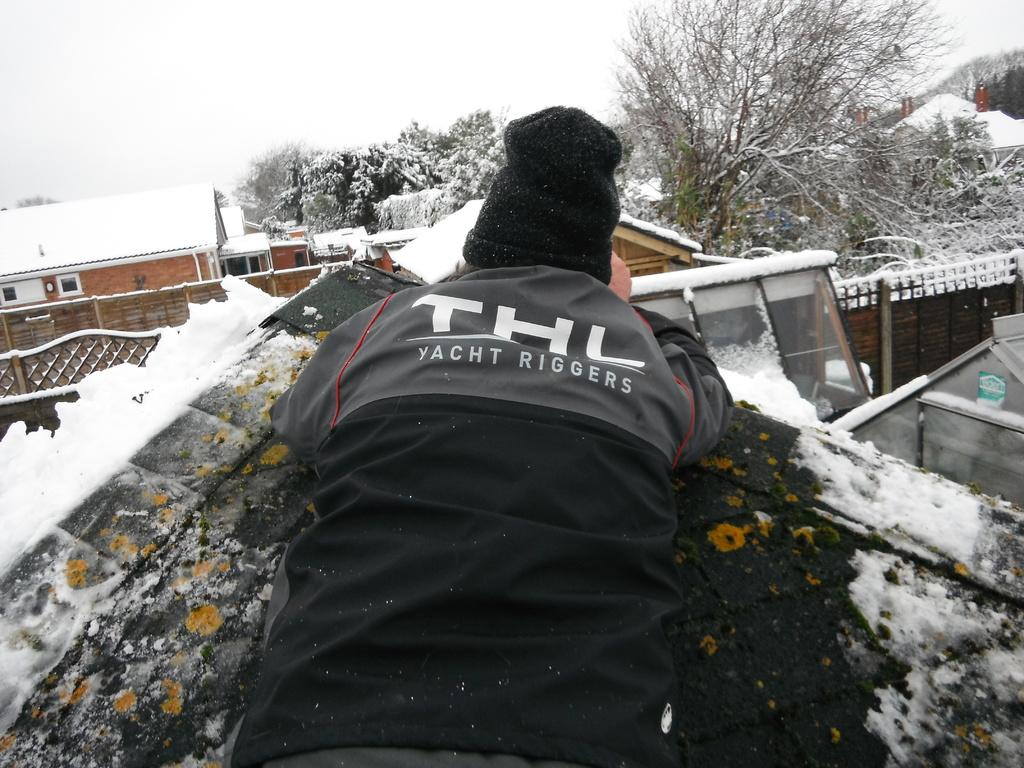Where was the picture taken? The picture was taken outside. What is the main subject in the center of the image? There is a person in the center of the image. What is the weather like in the image? There is a lot of snow visible in the image. What can be seen in the background of the image? There are trees, houses, and other objects visible in the background of the image. What type of bag is the person carrying in the image? There is no bag visible in the image. What kind of loaf is the person holding in the image? There is no loaf present in the image. 